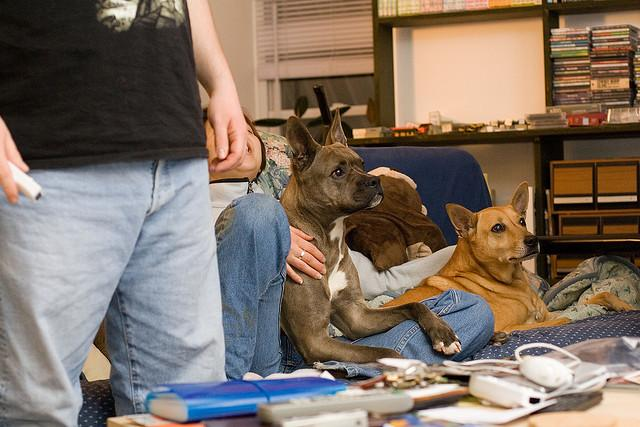Where are these people located? home 